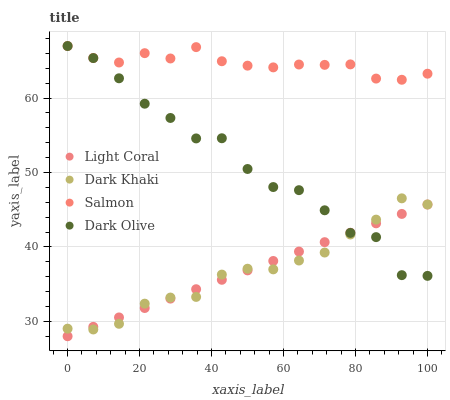Does Dark Khaki have the minimum area under the curve?
Answer yes or no. Yes. Does Salmon have the maximum area under the curve?
Answer yes or no. Yes. Does Dark Olive have the minimum area under the curve?
Answer yes or no. No. Does Dark Olive have the maximum area under the curve?
Answer yes or no. No. Is Light Coral the smoothest?
Answer yes or no. Yes. Is Dark Olive the roughest?
Answer yes or no. Yes. Is Dark Khaki the smoothest?
Answer yes or no. No. Is Dark Khaki the roughest?
Answer yes or no. No. Does Light Coral have the lowest value?
Answer yes or no. Yes. Does Dark Khaki have the lowest value?
Answer yes or no. No. Does Salmon have the highest value?
Answer yes or no. Yes. Does Dark Khaki have the highest value?
Answer yes or no. No. Is Dark Khaki less than Salmon?
Answer yes or no. Yes. Is Salmon greater than Light Coral?
Answer yes or no. Yes. Does Dark Khaki intersect Dark Olive?
Answer yes or no. Yes. Is Dark Khaki less than Dark Olive?
Answer yes or no. No. Is Dark Khaki greater than Dark Olive?
Answer yes or no. No. Does Dark Khaki intersect Salmon?
Answer yes or no. No. 